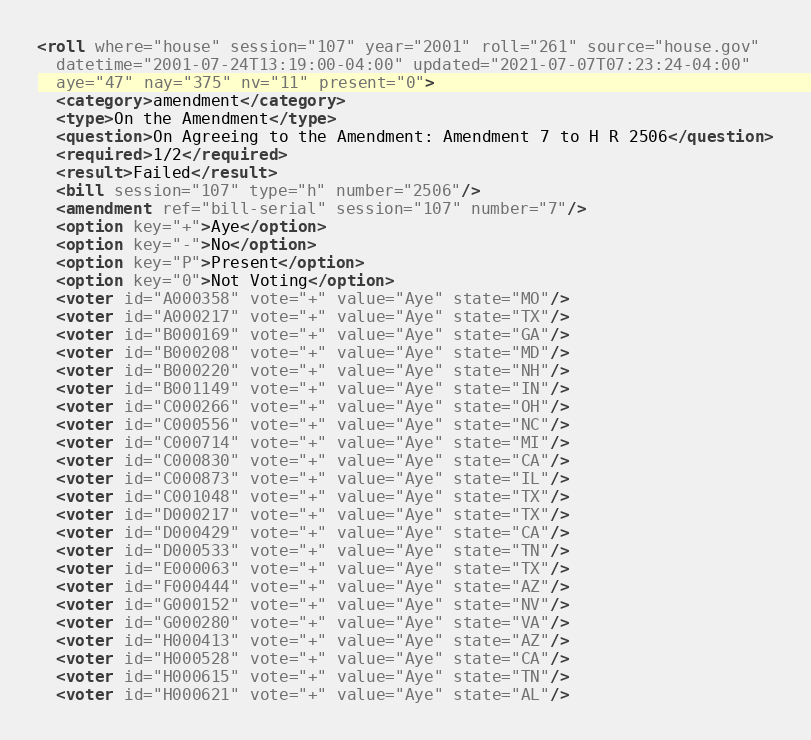Convert code to text. <code><loc_0><loc_0><loc_500><loc_500><_XML_><roll where="house" session="107" year="2001" roll="261" source="house.gov"
  datetime="2001-07-24T13:19:00-04:00" updated="2021-07-07T07:23:24-04:00"
  aye="47" nay="375" nv="11" present="0">
  <category>amendment</category>
  <type>On the Amendment</type>
  <question>On Agreeing to the Amendment: Amendment 7 to H R 2506</question>
  <required>1/2</required>
  <result>Failed</result>
  <bill session="107" type="h" number="2506"/>
  <amendment ref="bill-serial" session="107" number="7"/>
  <option key="+">Aye</option>
  <option key="-">No</option>
  <option key="P">Present</option>
  <option key="0">Not Voting</option>
  <voter id="A000358" vote="+" value="Aye" state="MO"/>
  <voter id="A000217" vote="+" value="Aye" state="TX"/>
  <voter id="B000169" vote="+" value="Aye" state="GA"/>
  <voter id="B000208" vote="+" value="Aye" state="MD"/>
  <voter id="B000220" vote="+" value="Aye" state="NH"/>
  <voter id="B001149" vote="+" value="Aye" state="IN"/>
  <voter id="C000266" vote="+" value="Aye" state="OH"/>
  <voter id="C000556" vote="+" value="Aye" state="NC"/>
  <voter id="C000714" vote="+" value="Aye" state="MI"/>
  <voter id="C000830" vote="+" value="Aye" state="CA"/>
  <voter id="C000873" vote="+" value="Aye" state="IL"/>
  <voter id="C001048" vote="+" value="Aye" state="TX"/>
  <voter id="D000217" vote="+" value="Aye" state="TX"/>
  <voter id="D000429" vote="+" value="Aye" state="CA"/>
  <voter id="D000533" vote="+" value="Aye" state="TN"/>
  <voter id="E000063" vote="+" value="Aye" state="TX"/>
  <voter id="F000444" vote="+" value="Aye" state="AZ"/>
  <voter id="G000152" vote="+" value="Aye" state="NV"/>
  <voter id="G000280" vote="+" value="Aye" state="VA"/>
  <voter id="H000413" vote="+" value="Aye" state="AZ"/>
  <voter id="H000528" vote="+" value="Aye" state="CA"/>
  <voter id="H000615" vote="+" value="Aye" state="TN"/>
  <voter id="H000621" vote="+" value="Aye" state="AL"/></code> 